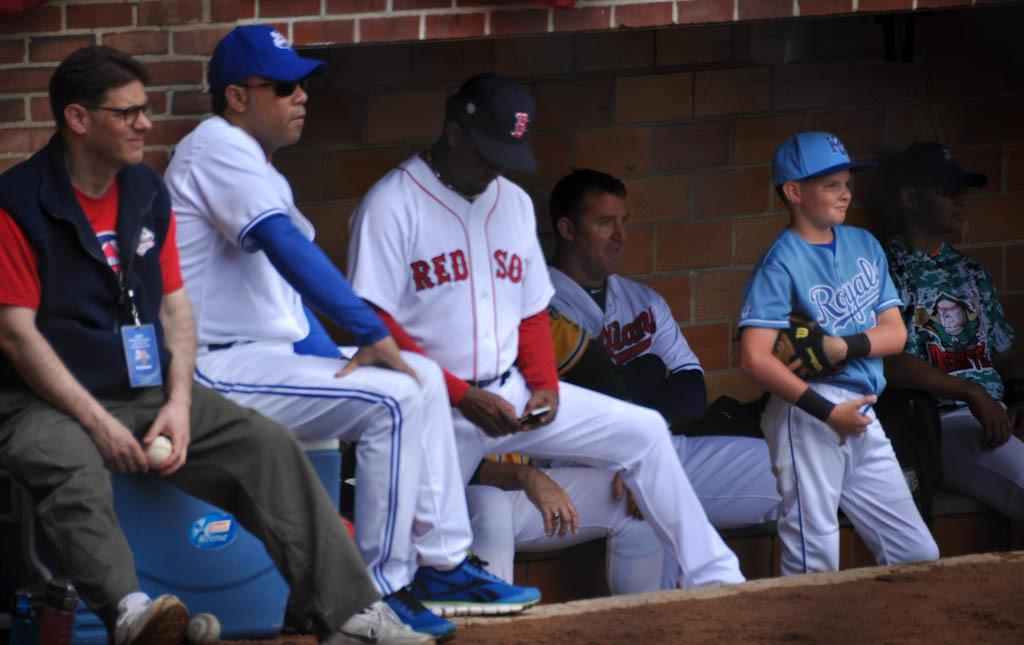<image>
Give a short and clear explanation of the subsequent image. a Red Sox jersey is on the person in the dugout 